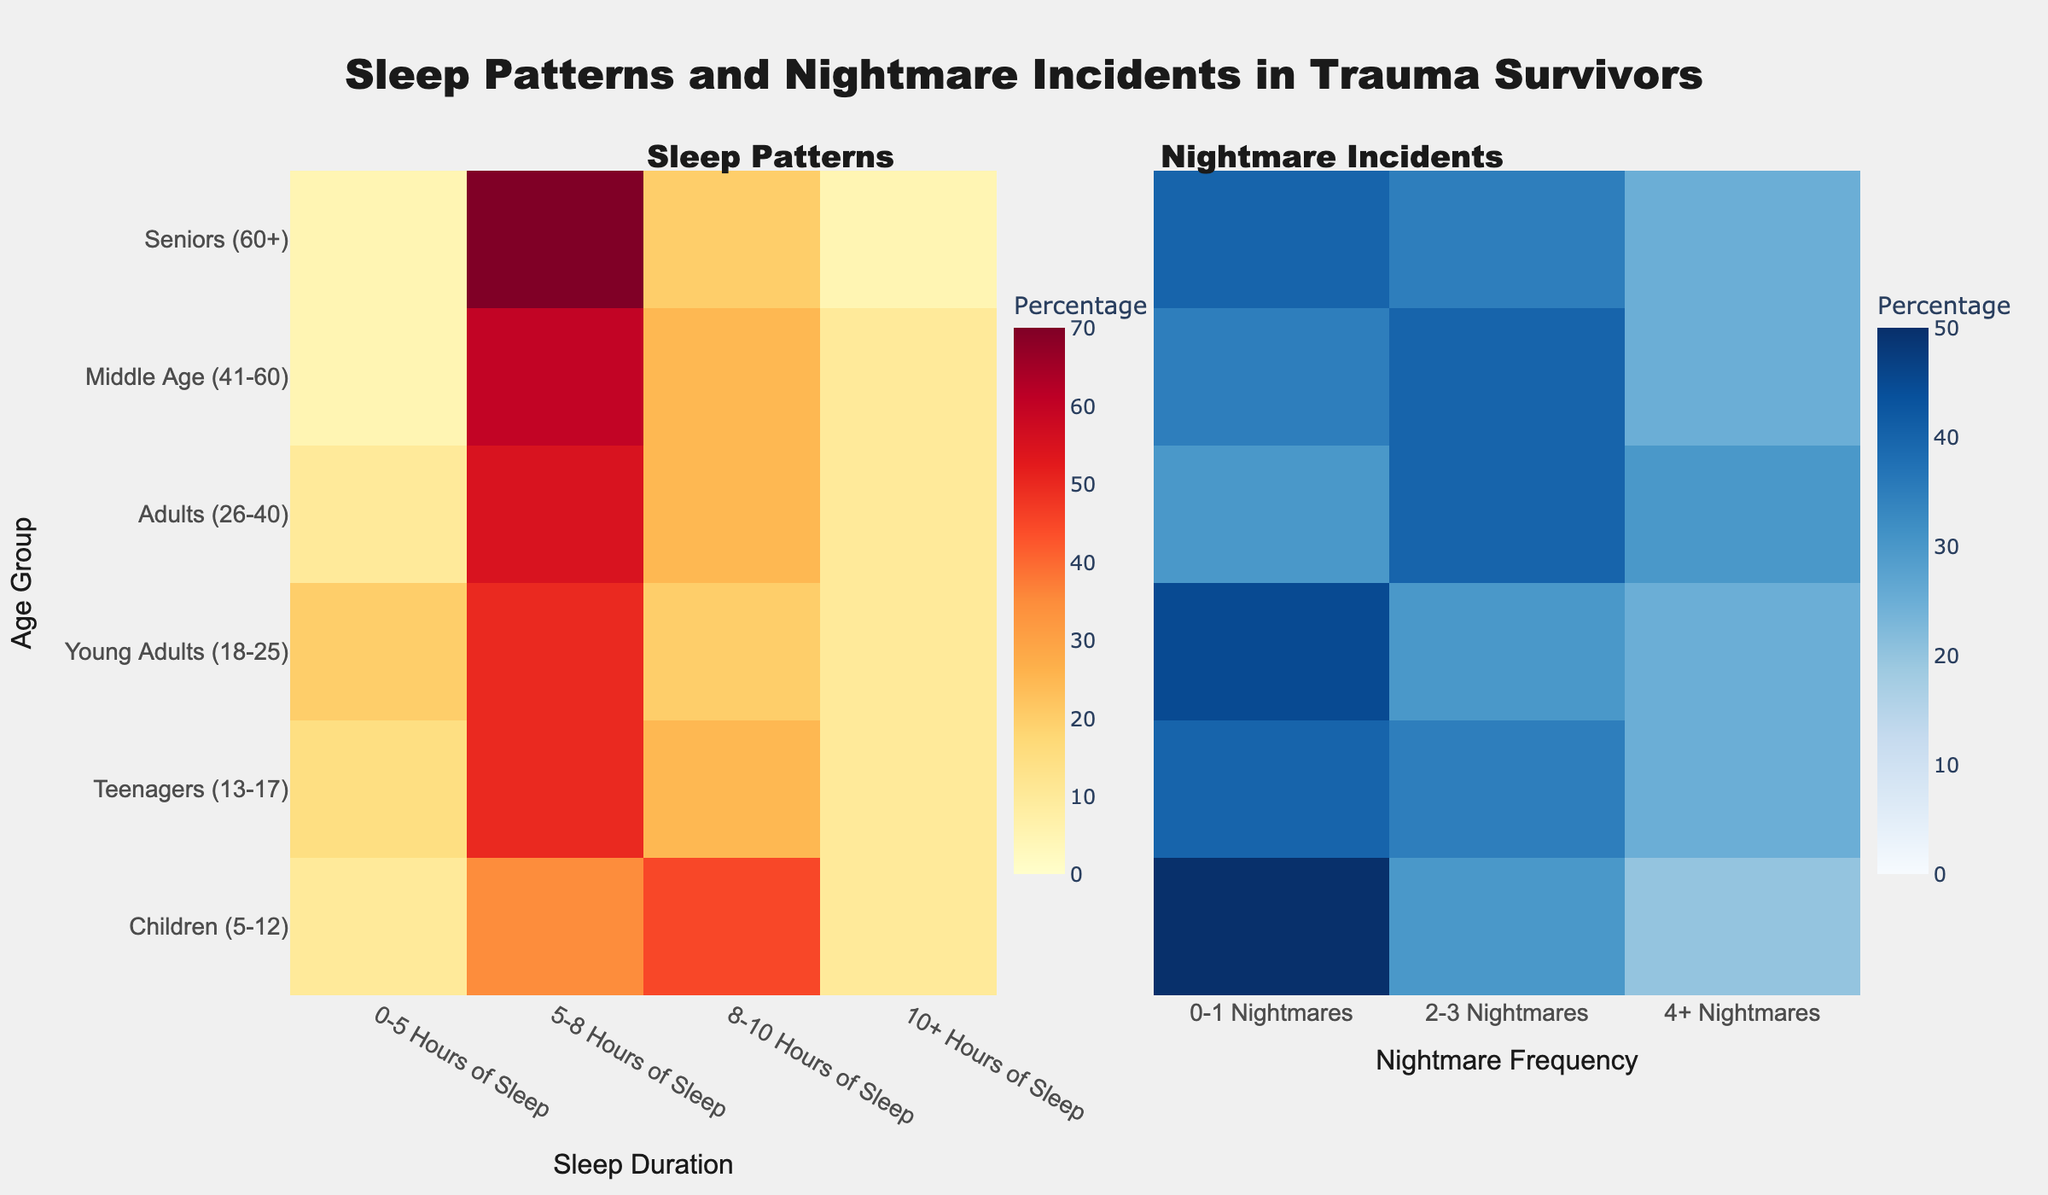What is the title of the figure? The title of the figure is positioned at the top center and reads "Sleep Patterns and Nightmare Incidents in Trauma Survivors".
Answer: Sleep Patterns and Nightmare Incidents in Trauma Survivors Which age group has the highest percentage of people sleeping 5-8 hours? Look at the heatmap under the "Sleep Duration" heading. Identify the highest value in the "5-8 Hours of Sleep" column.
Answer: Seniors (60+) What is the total percentage of nightmares for Young Adults (18-25)? Sum the percentages in the "0-1 Nightmares", "2-3 Nightmares", and "4+ Nightmares" columns for Young Adults. 45 + 30 + 25 = 100%.
Answer: 100% Between Children (5-12) and Teenagers (13-17), which group has a higher percentage of 0-5 hours of sleep? Compare the values in the "0-5 Hours of Sleep" row for both age groups. Children have 10% and Teenagers have 15%.
Answer: Teenagers (13-17) Which category has no age group with a zero percentage? Scan all columns to identify if there's any category with no zero percentages. Both "Sleep Duration" and "Nightmare Frequency" categories have no zeros.
Answer: Sleep Duration and Nightmare Frequency What percentage of Middle Age (41-60) individuals experience 2-3 nightmares? Locate the "Middle Age (41-60)" row and find the value under the "2-3 Nightmares" column, which is 40%.
Answer: 40% Which sleep duration category is most common among the Seniors (60+) group? Look at the "Seniors (60+)" row and identify the highest percentage in the sleep duration columns (0-5, 5-8, 8-10, 10+). The highest percentage is in the "5-8 Hours of Sleep" column which is 70%.
Answer: 5-8 Hours of Sleep What is the percentage difference in experiencing 4+ nightmares between Children (5-12) and Adults (26-40)? Subtract the percentage of 4+ nightmares for Children (20%) from Adults (30%). 30% - 20% = 10%.
Answer: 10% Do more Children (5-12) or Teenagers (13-17) experience 0-1 nightmares? Compare the "0-1 Nightmares" percentages between Children (50%) and Teenagers (40%).
Answer: Children (5-12) What is the main color scale used for representing nightmare incidents? The color scale under the "Nightmare Incidents" section shows various shades of blue.
Answer: Blues 